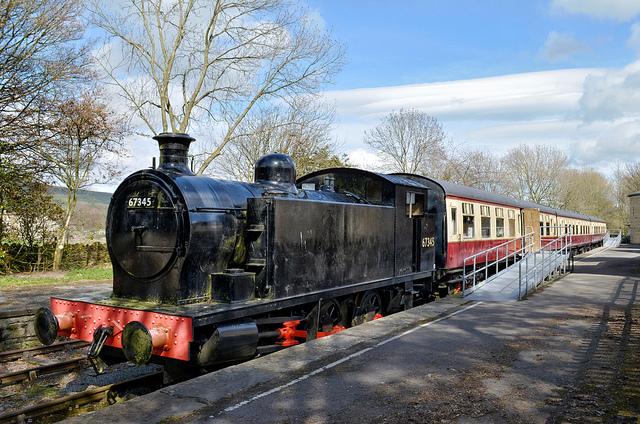Does this train haul materials?
Give a very brief answer. No. Is this a passenger train?
Concise answer only. Yes. What color is the front of the train?
Be succinct. Black. Is the train moving?
Write a very short answer. No. Is this a modern engine?
Concise answer only. No. What color is the engine?
Keep it brief. Black. 